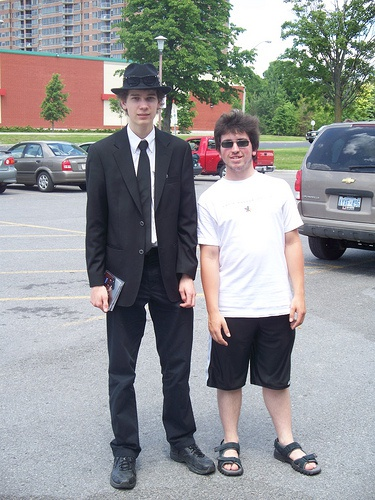Describe the objects in this image and their specific colors. I can see people in beige, black, and gray tones, people in beige, white, black, darkgray, and lightpink tones, car in beige, darkgray, gray, black, and darkblue tones, car in beige, gray, darkgray, lightgray, and black tones, and truck in beige, salmon, gray, brown, and black tones in this image. 